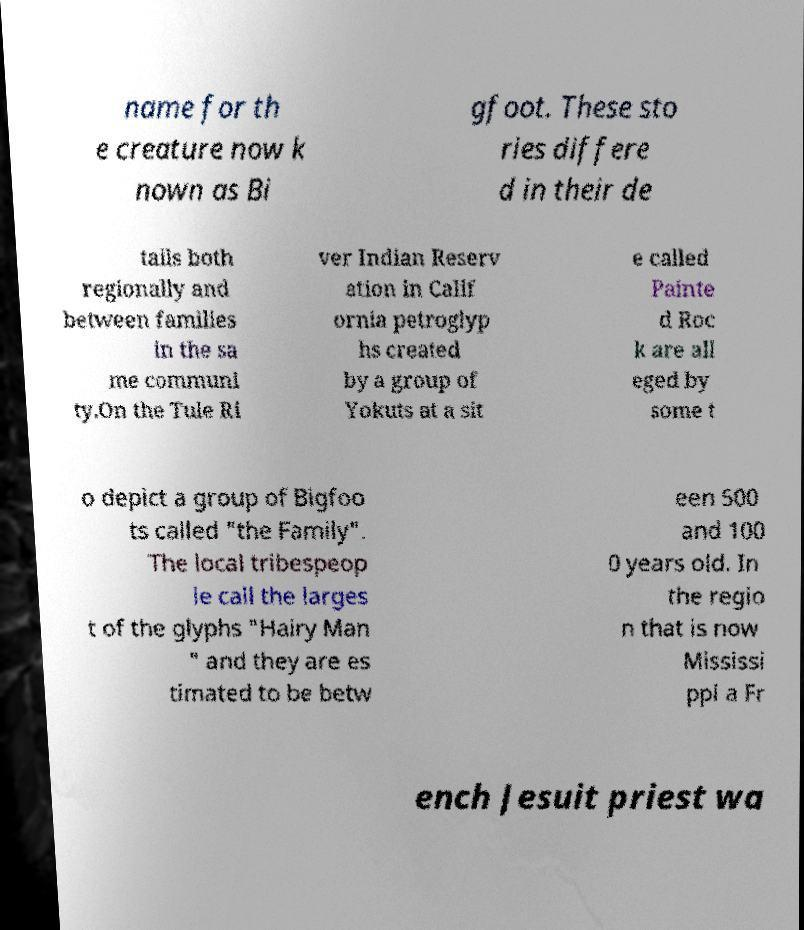There's text embedded in this image that I need extracted. Can you transcribe it verbatim? name for th e creature now k nown as Bi gfoot. These sto ries differe d in their de tails both regionally and between families in the sa me communi ty.On the Tule Ri ver Indian Reserv ation in Calif ornia petroglyp hs created by a group of Yokuts at a sit e called Painte d Roc k are all eged by some t o depict a group of Bigfoo ts called "the Family". The local tribespeop le call the larges t of the glyphs "Hairy Man " and they are es timated to be betw een 500 and 100 0 years old. In the regio n that is now Mississi ppi a Fr ench Jesuit priest wa 